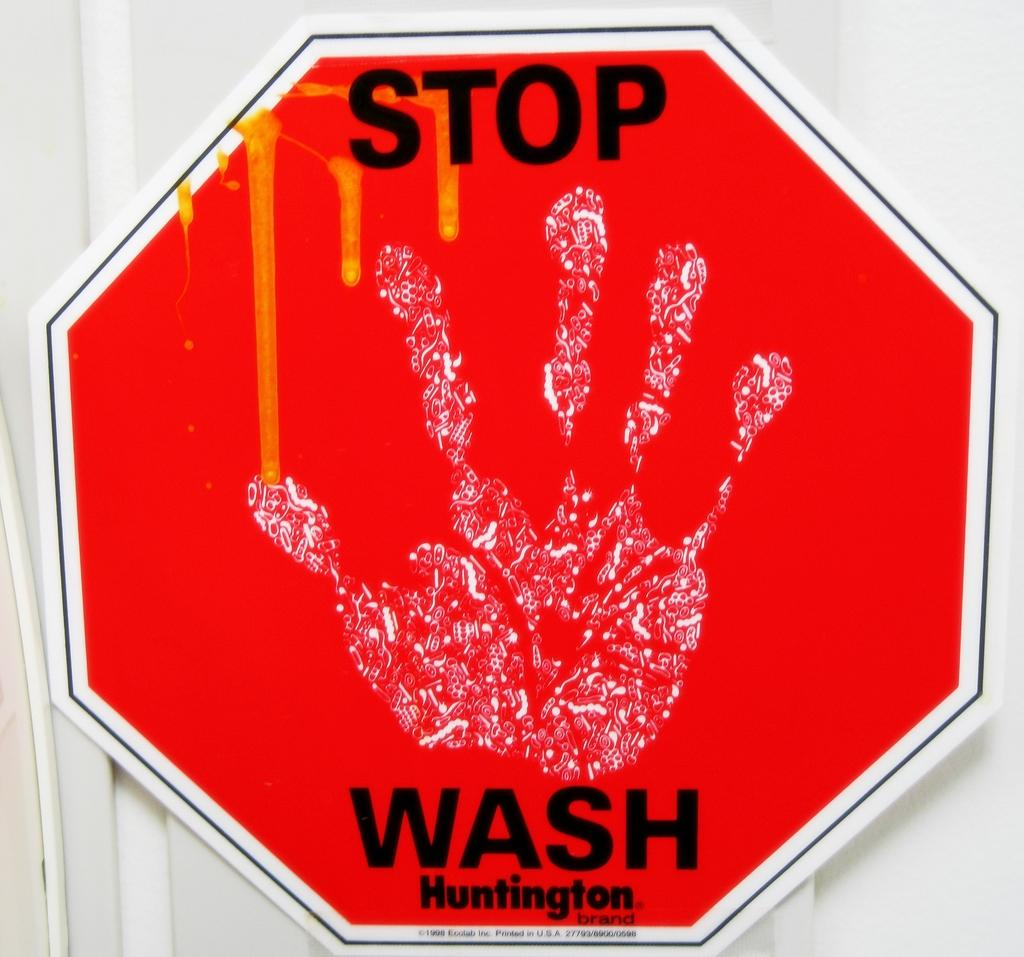<image>
Give a short and clear explanation of the subsequent image. a stop wash sign that has a hand on it 